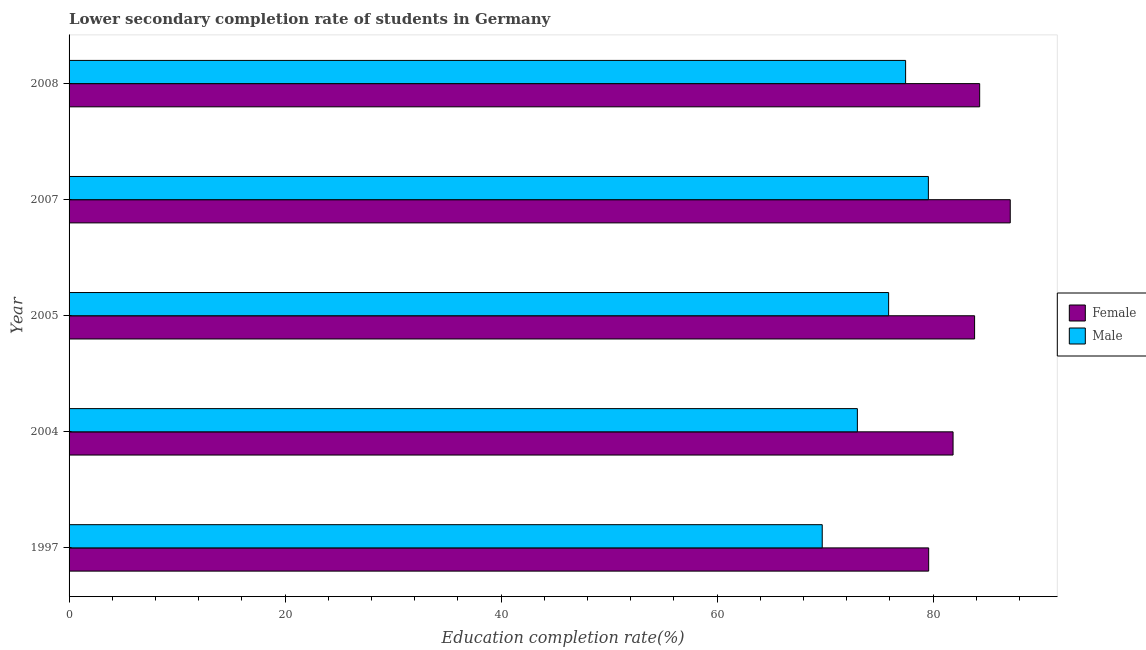How many different coloured bars are there?
Ensure brevity in your answer.  2. Are the number of bars per tick equal to the number of legend labels?
Keep it short and to the point. Yes. How many bars are there on the 5th tick from the top?
Your answer should be very brief. 2. What is the label of the 2nd group of bars from the top?
Your answer should be very brief. 2007. What is the education completion rate of female students in 2005?
Your answer should be very brief. 83.85. Across all years, what is the maximum education completion rate of female students?
Offer a terse response. 87.15. Across all years, what is the minimum education completion rate of male students?
Keep it short and to the point. 69.74. In which year was the education completion rate of male students maximum?
Make the answer very short. 2007. In which year was the education completion rate of female students minimum?
Your answer should be compact. 1997. What is the total education completion rate of male students in the graph?
Offer a very short reply. 375.67. What is the difference between the education completion rate of female students in 1997 and that in 2008?
Offer a very short reply. -4.72. What is the difference between the education completion rate of female students in 2005 and the education completion rate of male students in 2007?
Offer a terse response. 4.28. What is the average education completion rate of female students per year?
Keep it short and to the point. 83.36. In the year 2005, what is the difference between the education completion rate of female students and education completion rate of male students?
Provide a succinct answer. 7.96. In how many years, is the education completion rate of female students greater than 4 %?
Your answer should be compact. 5. What is the difference between the highest and the second highest education completion rate of female students?
Provide a short and direct response. 2.83. What is the difference between the highest and the lowest education completion rate of male students?
Offer a very short reply. 9.83. How many bars are there?
Offer a terse response. 10. What is the difference between two consecutive major ticks on the X-axis?
Ensure brevity in your answer.  20. Are the values on the major ticks of X-axis written in scientific E-notation?
Your response must be concise. No. Where does the legend appear in the graph?
Offer a terse response. Center right. How many legend labels are there?
Make the answer very short. 2. How are the legend labels stacked?
Provide a succinct answer. Vertical. What is the title of the graph?
Your answer should be compact. Lower secondary completion rate of students in Germany. What is the label or title of the X-axis?
Keep it short and to the point. Education completion rate(%). What is the label or title of the Y-axis?
Keep it short and to the point. Year. What is the Education completion rate(%) of Female in 1997?
Provide a short and direct response. 79.6. What is the Education completion rate(%) of Male in 1997?
Keep it short and to the point. 69.74. What is the Education completion rate(%) in Female in 2004?
Your answer should be very brief. 81.86. What is the Education completion rate(%) in Male in 2004?
Keep it short and to the point. 73. What is the Education completion rate(%) in Female in 2005?
Your answer should be very brief. 83.85. What is the Education completion rate(%) in Male in 2005?
Offer a terse response. 75.89. What is the Education completion rate(%) in Female in 2007?
Give a very brief answer. 87.15. What is the Education completion rate(%) in Male in 2007?
Keep it short and to the point. 79.57. What is the Education completion rate(%) in Female in 2008?
Provide a short and direct response. 84.32. What is the Education completion rate(%) of Male in 2008?
Make the answer very short. 77.46. Across all years, what is the maximum Education completion rate(%) of Female?
Offer a very short reply. 87.15. Across all years, what is the maximum Education completion rate(%) in Male?
Your answer should be compact. 79.57. Across all years, what is the minimum Education completion rate(%) of Female?
Offer a terse response. 79.6. Across all years, what is the minimum Education completion rate(%) of Male?
Make the answer very short. 69.74. What is the total Education completion rate(%) in Female in the graph?
Your answer should be compact. 416.79. What is the total Education completion rate(%) of Male in the graph?
Keep it short and to the point. 375.67. What is the difference between the Education completion rate(%) in Female in 1997 and that in 2004?
Your response must be concise. -2.26. What is the difference between the Education completion rate(%) of Male in 1997 and that in 2004?
Your answer should be compact. -3.25. What is the difference between the Education completion rate(%) in Female in 1997 and that in 2005?
Your answer should be compact. -4.25. What is the difference between the Education completion rate(%) of Male in 1997 and that in 2005?
Your response must be concise. -6.15. What is the difference between the Education completion rate(%) in Female in 1997 and that in 2007?
Offer a terse response. -7.55. What is the difference between the Education completion rate(%) of Male in 1997 and that in 2007?
Your answer should be very brief. -9.83. What is the difference between the Education completion rate(%) in Female in 1997 and that in 2008?
Your answer should be compact. -4.72. What is the difference between the Education completion rate(%) in Male in 1997 and that in 2008?
Your answer should be very brief. -7.72. What is the difference between the Education completion rate(%) in Female in 2004 and that in 2005?
Provide a short and direct response. -1.99. What is the difference between the Education completion rate(%) of Male in 2004 and that in 2005?
Make the answer very short. -2.89. What is the difference between the Education completion rate(%) in Female in 2004 and that in 2007?
Give a very brief answer. -5.29. What is the difference between the Education completion rate(%) in Male in 2004 and that in 2007?
Offer a very short reply. -6.57. What is the difference between the Education completion rate(%) of Female in 2004 and that in 2008?
Your answer should be very brief. -2.46. What is the difference between the Education completion rate(%) of Male in 2004 and that in 2008?
Keep it short and to the point. -4.47. What is the difference between the Education completion rate(%) of Female in 2005 and that in 2007?
Offer a very short reply. -3.3. What is the difference between the Education completion rate(%) of Male in 2005 and that in 2007?
Give a very brief answer. -3.68. What is the difference between the Education completion rate(%) of Female in 2005 and that in 2008?
Your answer should be very brief. -0.47. What is the difference between the Education completion rate(%) of Male in 2005 and that in 2008?
Offer a very short reply. -1.57. What is the difference between the Education completion rate(%) in Female in 2007 and that in 2008?
Give a very brief answer. 2.83. What is the difference between the Education completion rate(%) in Male in 2007 and that in 2008?
Offer a terse response. 2.11. What is the difference between the Education completion rate(%) of Female in 1997 and the Education completion rate(%) of Male in 2004?
Give a very brief answer. 6.6. What is the difference between the Education completion rate(%) of Female in 1997 and the Education completion rate(%) of Male in 2005?
Your answer should be compact. 3.71. What is the difference between the Education completion rate(%) of Female in 1997 and the Education completion rate(%) of Male in 2007?
Provide a succinct answer. 0.03. What is the difference between the Education completion rate(%) in Female in 1997 and the Education completion rate(%) in Male in 2008?
Give a very brief answer. 2.14. What is the difference between the Education completion rate(%) of Female in 2004 and the Education completion rate(%) of Male in 2005?
Provide a short and direct response. 5.97. What is the difference between the Education completion rate(%) of Female in 2004 and the Education completion rate(%) of Male in 2007?
Offer a very short reply. 2.29. What is the difference between the Education completion rate(%) in Female in 2004 and the Education completion rate(%) in Male in 2008?
Give a very brief answer. 4.39. What is the difference between the Education completion rate(%) of Female in 2005 and the Education completion rate(%) of Male in 2007?
Your answer should be very brief. 4.28. What is the difference between the Education completion rate(%) in Female in 2005 and the Education completion rate(%) in Male in 2008?
Ensure brevity in your answer.  6.39. What is the difference between the Education completion rate(%) of Female in 2007 and the Education completion rate(%) of Male in 2008?
Make the answer very short. 9.69. What is the average Education completion rate(%) of Female per year?
Make the answer very short. 83.36. What is the average Education completion rate(%) of Male per year?
Make the answer very short. 75.13. In the year 1997, what is the difference between the Education completion rate(%) in Female and Education completion rate(%) in Male?
Your response must be concise. 9.86. In the year 2004, what is the difference between the Education completion rate(%) of Female and Education completion rate(%) of Male?
Give a very brief answer. 8.86. In the year 2005, what is the difference between the Education completion rate(%) in Female and Education completion rate(%) in Male?
Your response must be concise. 7.96. In the year 2007, what is the difference between the Education completion rate(%) of Female and Education completion rate(%) of Male?
Your answer should be compact. 7.58. In the year 2008, what is the difference between the Education completion rate(%) in Female and Education completion rate(%) in Male?
Give a very brief answer. 6.86. What is the ratio of the Education completion rate(%) of Female in 1997 to that in 2004?
Offer a very short reply. 0.97. What is the ratio of the Education completion rate(%) of Male in 1997 to that in 2004?
Your answer should be compact. 0.96. What is the ratio of the Education completion rate(%) in Female in 1997 to that in 2005?
Provide a short and direct response. 0.95. What is the ratio of the Education completion rate(%) of Male in 1997 to that in 2005?
Your answer should be very brief. 0.92. What is the ratio of the Education completion rate(%) in Female in 1997 to that in 2007?
Offer a terse response. 0.91. What is the ratio of the Education completion rate(%) in Male in 1997 to that in 2007?
Provide a succinct answer. 0.88. What is the ratio of the Education completion rate(%) in Female in 1997 to that in 2008?
Keep it short and to the point. 0.94. What is the ratio of the Education completion rate(%) of Male in 1997 to that in 2008?
Make the answer very short. 0.9. What is the ratio of the Education completion rate(%) in Female in 2004 to that in 2005?
Offer a very short reply. 0.98. What is the ratio of the Education completion rate(%) of Male in 2004 to that in 2005?
Provide a short and direct response. 0.96. What is the ratio of the Education completion rate(%) of Female in 2004 to that in 2007?
Your answer should be very brief. 0.94. What is the ratio of the Education completion rate(%) of Male in 2004 to that in 2007?
Ensure brevity in your answer.  0.92. What is the ratio of the Education completion rate(%) in Female in 2004 to that in 2008?
Your response must be concise. 0.97. What is the ratio of the Education completion rate(%) in Male in 2004 to that in 2008?
Make the answer very short. 0.94. What is the ratio of the Education completion rate(%) in Female in 2005 to that in 2007?
Keep it short and to the point. 0.96. What is the ratio of the Education completion rate(%) of Male in 2005 to that in 2007?
Your response must be concise. 0.95. What is the ratio of the Education completion rate(%) in Male in 2005 to that in 2008?
Provide a short and direct response. 0.98. What is the ratio of the Education completion rate(%) of Female in 2007 to that in 2008?
Offer a terse response. 1.03. What is the ratio of the Education completion rate(%) in Male in 2007 to that in 2008?
Make the answer very short. 1.03. What is the difference between the highest and the second highest Education completion rate(%) in Female?
Your answer should be compact. 2.83. What is the difference between the highest and the second highest Education completion rate(%) of Male?
Your answer should be very brief. 2.11. What is the difference between the highest and the lowest Education completion rate(%) of Female?
Provide a succinct answer. 7.55. What is the difference between the highest and the lowest Education completion rate(%) in Male?
Keep it short and to the point. 9.83. 